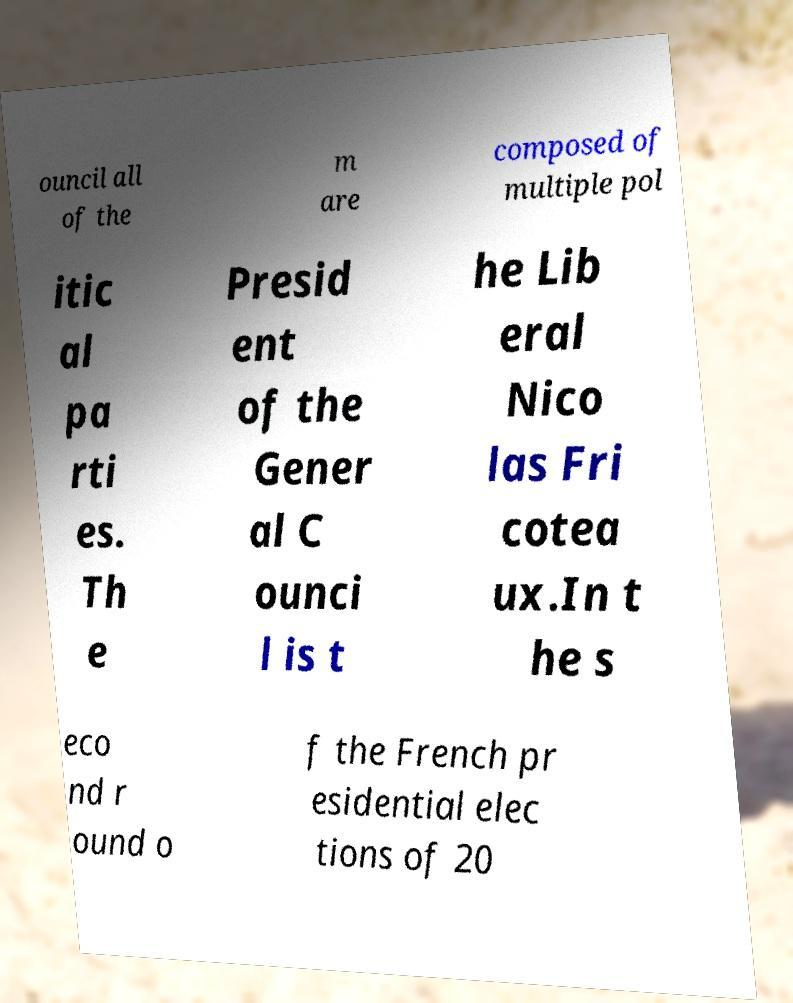Could you assist in decoding the text presented in this image and type it out clearly? ouncil all of the m are composed of multiple pol itic al pa rti es. Th e Presid ent of the Gener al C ounci l is t he Lib eral Nico las Fri cotea ux.In t he s eco nd r ound o f the French pr esidential elec tions of 20 